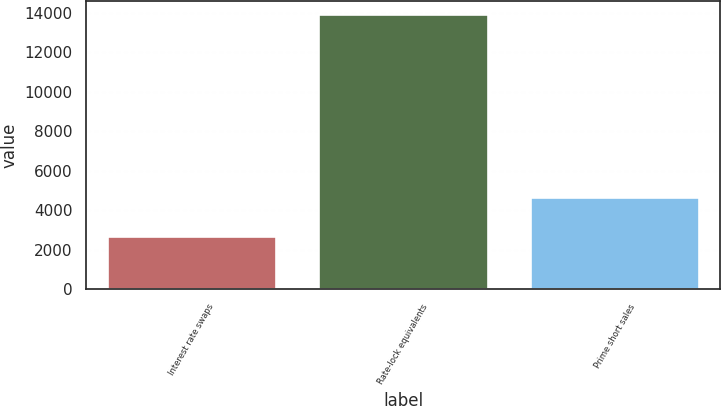<chart> <loc_0><loc_0><loc_500><loc_500><bar_chart><fcel>Interest rate swaps<fcel>Rate-lock equivalents<fcel>Prime short sales<nl><fcel>2703<fcel>13917<fcel>4663<nl></chart> 